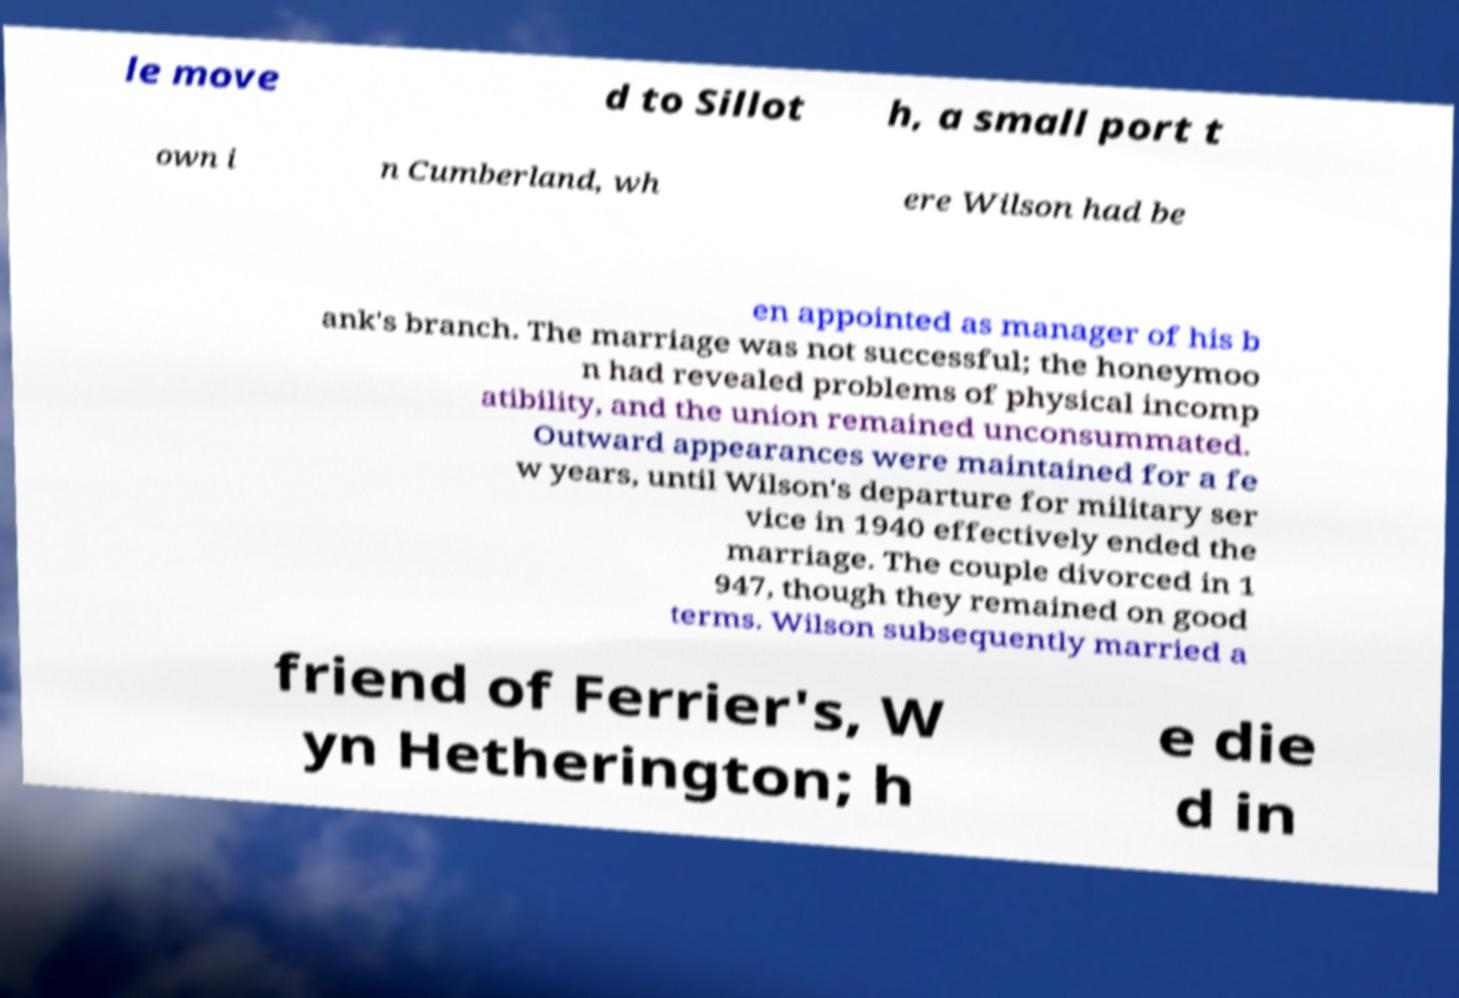Could you extract and type out the text from this image? le move d to Sillot h, a small port t own i n Cumberland, wh ere Wilson had be en appointed as manager of his b ank's branch. The marriage was not successful; the honeymoo n had revealed problems of physical incomp atibility, and the union remained unconsummated. Outward appearances were maintained for a fe w years, until Wilson's departure for military ser vice in 1940 effectively ended the marriage. The couple divorced in 1 947, though they remained on good terms. Wilson subsequently married a friend of Ferrier's, W yn Hetherington; h e die d in 